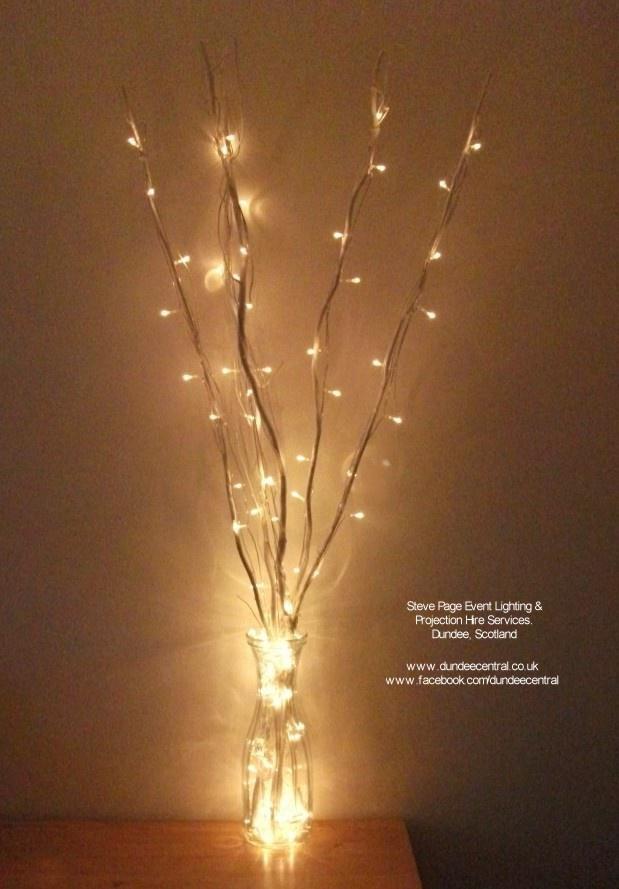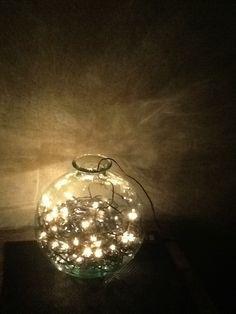The first image is the image on the left, the second image is the image on the right. Analyze the images presented: Is the assertion "At least 1 glass container is decorated with pine cones and lights." valid? Answer yes or no. No. The first image is the image on the left, the second image is the image on the right. Considering the images on both sides, is "There are pine cones in at least one clear glass vase with stringed lights inside with them." valid? Answer yes or no. No. 